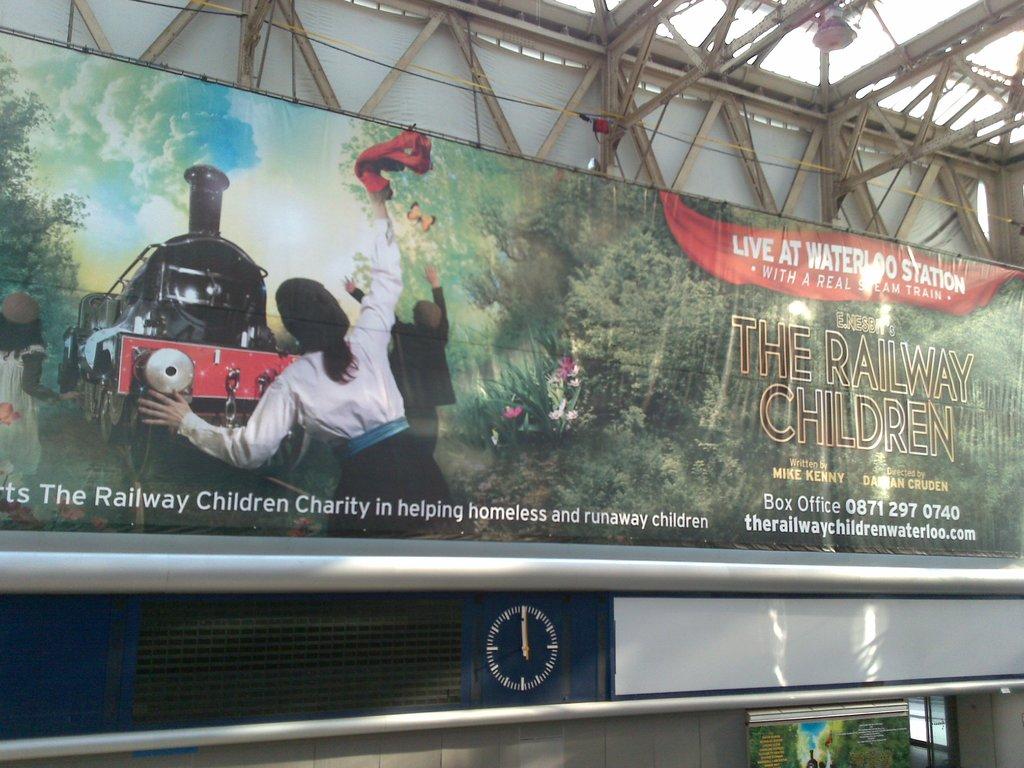Who does the charity attempt to help?
Give a very brief answer. Homeless and runaway children. 